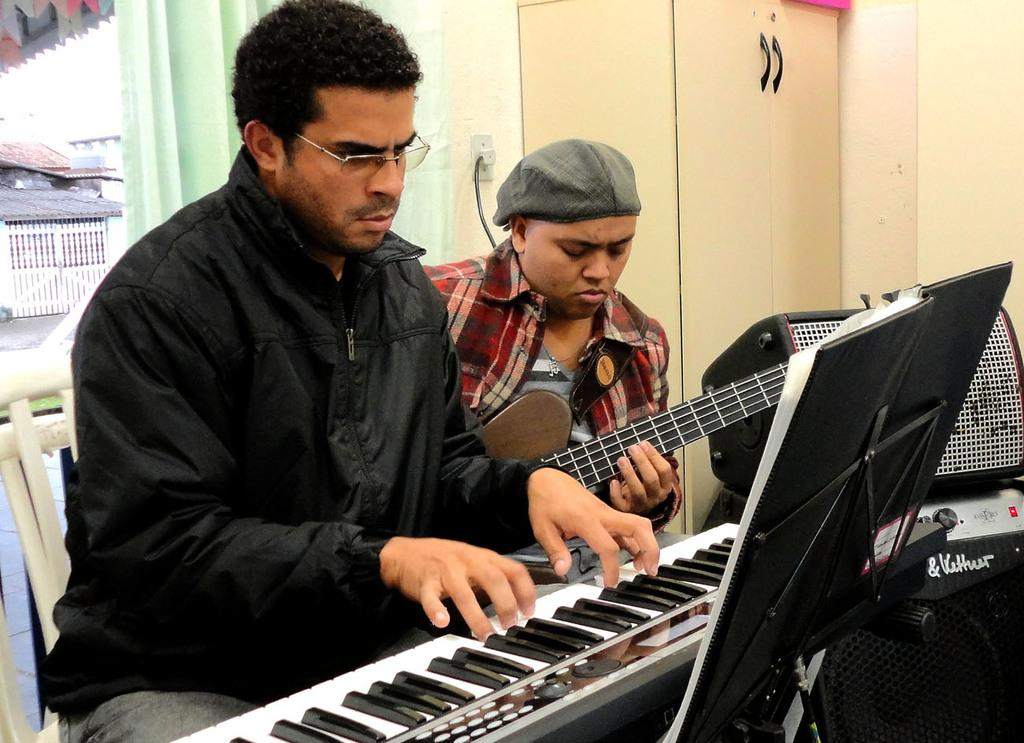How many people are in the image? There are two persons in the image. What are the persons doing in the image? The persons are sitting and playing musical instruments. What can be seen in the background of the image? There is a cupboard and a curtain in the background of the image. What type of farming equipment can be seen in the image? There is no farming equipment present in the image. How does the family interact with each other in the image? There is no family present in the image, only two persons playing musical instruments. 